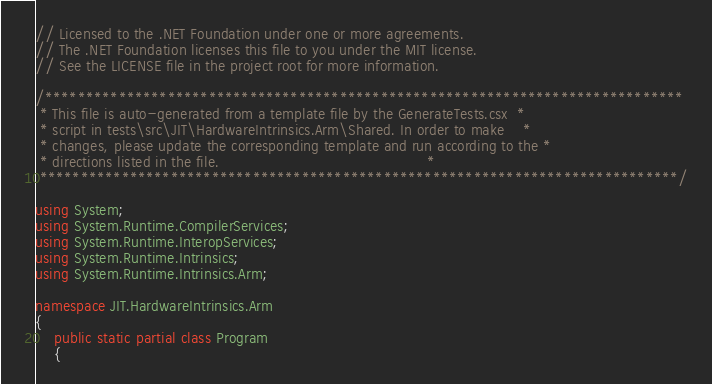<code> <loc_0><loc_0><loc_500><loc_500><_C#_>// Licensed to the .NET Foundation under one or more agreements.
// The .NET Foundation licenses this file to you under the MIT license.
// See the LICENSE file in the project root for more information.

/******************************************************************************
 * This file is auto-generated from a template file by the GenerateTests.csx  *
 * script in tests\src\JIT\HardwareIntrinsics.Arm\Shared. In order to make    *
 * changes, please update the corresponding template and run according to the *
 * directions listed in the file.                                             *
 ******************************************************************************/

using System;
using System.Runtime.CompilerServices;
using System.Runtime.InteropServices;
using System.Runtime.Intrinsics;
using System.Runtime.Intrinsics.Arm;

namespace JIT.HardwareIntrinsics.Arm
{
    public static partial class Program
    {</code> 